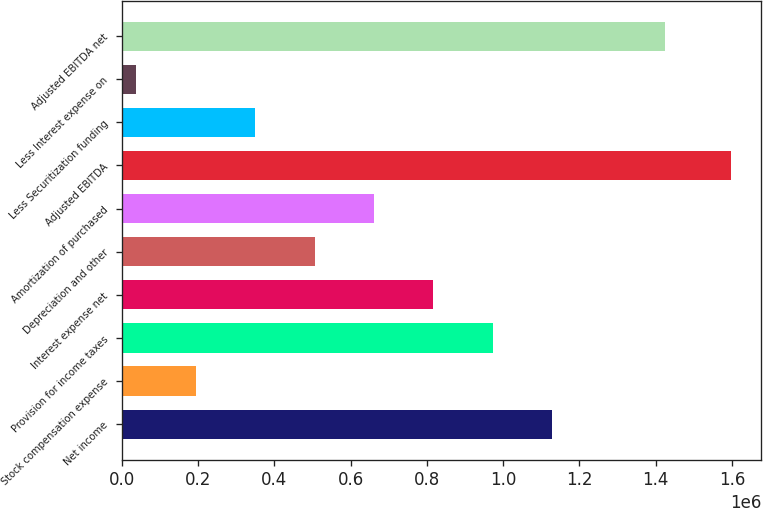Convert chart. <chart><loc_0><loc_0><loc_500><loc_500><bar_chart><fcel>Net income<fcel>Stock compensation expense<fcel>Provision for income taxes<fcel>Interest expense net<fcel>Depreciation and other<fcel>Amortization of purchased<fcel>Adjusted EBITDA<fcel>Less Securitization funding<fcel>Less Interest expense on<fcel>Adjusted EBITDA net<nl><fcel>1.12934e+06<fcel>193514<fcel>973371<fcel>817400<fcel>505457<fcel>661428<fcel>1.59726e+06<fcel>349486<fcel>37543<fcel>1.42556e+06<nl></chart> 